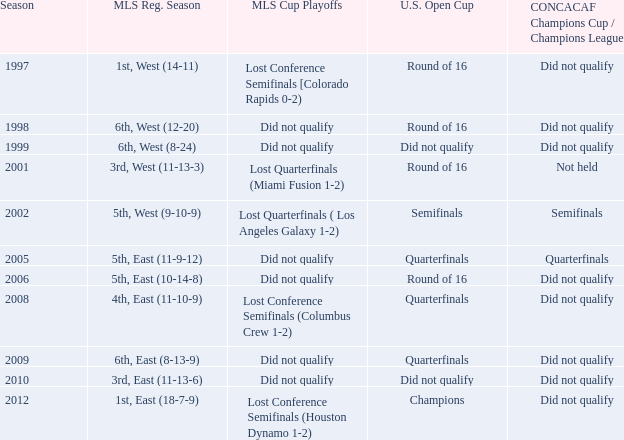What was the team's standing when they couldn't qualify for the concaf champions cup but progressed to the round of 16 in the u.s. open cup? Lost Conference Semifinals [Colorado Rapids 0-2), Did not qualify, Did not qualify. 